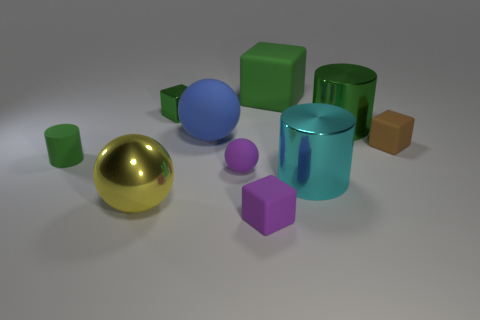Is the tiny matte cylinder the same color as the tiny ball?
Offer a very short reply. No. How many other objects are there of the same material as the yellow sphere?
Your answer should be compact. 3. There is a small object that is behind the tiny object on the right side of the green matte cube; what shape is it?
Provide a short and direct response. Cube. How big is the green block right of the tiny green block?
Give a very brief answer. Large. Is the material of the big cyan thing the same as the large yellow object?
Provide a short and direct response. Yes. What shape is the big blue thing that is the same material as the tiny sphere?
Give a very brief answer. Sphere. Is there any other thing that is the same color as the large matte ball?
Keep it short and to the point. No. There is a tiny matte thing on the right side of the purple matte cube; what color is it?
Ensure brevity in your answer.  Brown. Do the shiny thing on the right side of the cyan metallic cylinder and the rubber cylinder have the same color?
Make the answer very short. Yes. There is a big cyan object that is the same shape as the large green shiny object; what is it made of?
Offer a very short reply. Metal. 